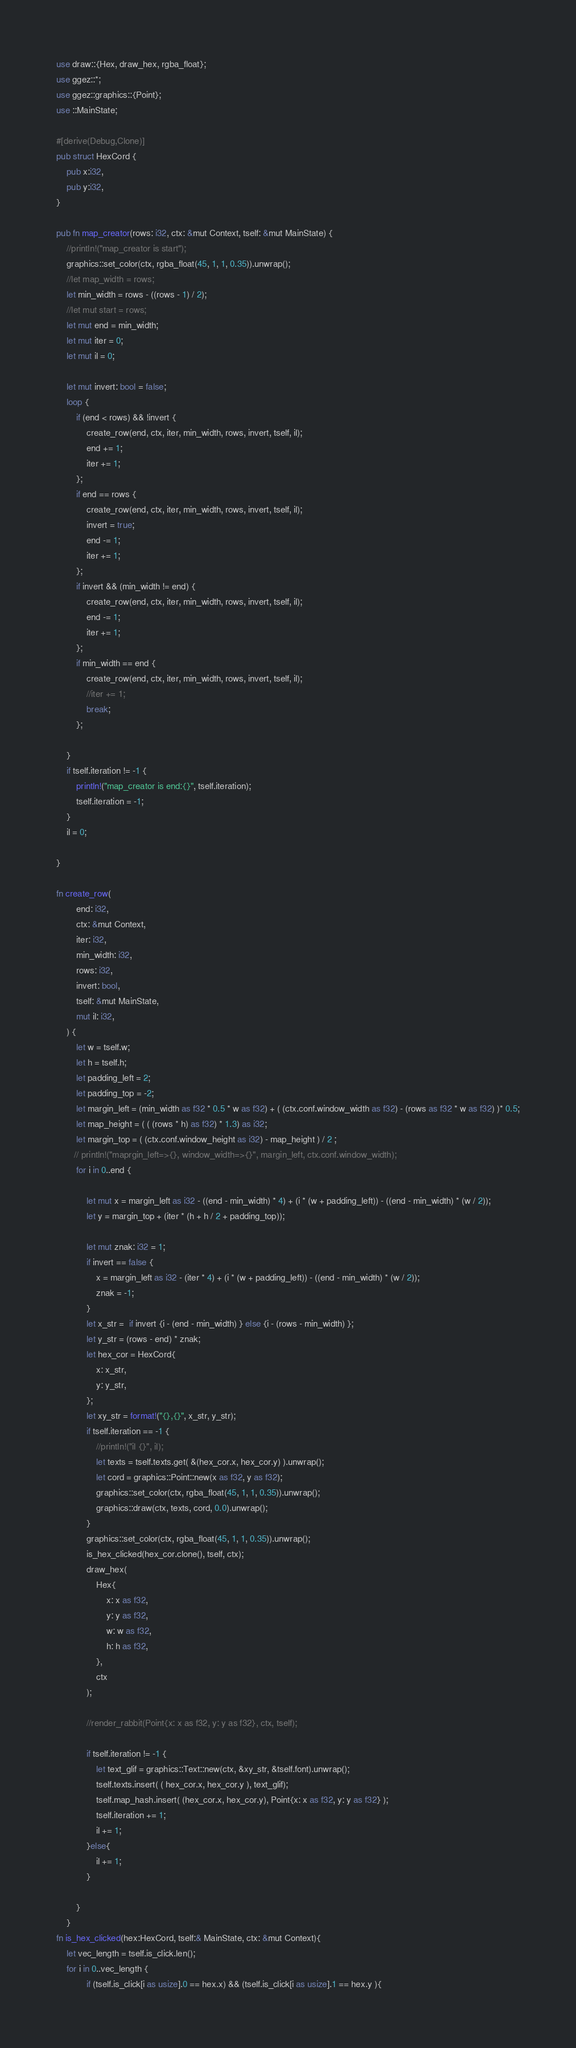Convert code to text. <code><loc_0><loc_0><loc_500><loc_500><_Rust_>use draw::{Hex, draw_hex, rgba_float};
use ggez::*;
use ggez::graphics::{Point};
use ::MainState;

#[derive(Debug,Clone)]
pub struct HexCord {
    pub x:i32,
    pub y:i32,
}

pub fn map_creator(rows: i32, ctx: &mut Context, tself: &mut MainState) {
    //println!("map_creator is start");
    graphics::set_color(ctx, rgba_float(45, 1, 1, 0.35)).unwrap();
    //let map_width = rows;
    let min_width = rows - ((rows - 1) / 2);
    //let mut start = rows;
    let mut end = min_width;
    let mut iter = 0;
    let mut il = 0;
    
    let mut invert: bool = false;
    loop {
        if (end < rows) && !invert {
            create_row(end, ctx, iter, min_width, rows, invert, tself, il);
            end += 1;
            iter += 1;
        };
        if end == rows {
            create_row(end, ctx, iter, min_width, rows, invert, tself, il);
            invert = true;
            end -= 1;
            iter += 1;
        };
        if invert && (min_width != end) {
            create_row(end, ctx, iter, min_width, rows, invert, tself, il);
            end -= 1;
            iter += 1;
        };
        if min_width == end {
            create_row(end, ctx, iter, min_width, rows, invert, tself, il);
            //iter += 1;
            break;
        };

    }
    if tself.iteration != -1 {
    	println!("map_creator is end:{}", tself.iteration);
    	tself.iteration = -1;
    }
    il = 0;
    
}

fn create_row(
        end: i32,
        ctx: &mut Context,
        iter: i32,
        min_width: i32,
        rows: i32,
        invert: bool,
        tself: &mut MainState,
        mut il: i32,
    ) {
        let w = tself.w;
        let h = tself.h;
        let padding_left = 2;
        let padding_top = -2;
        let margin_left = (min_width as f32 * 0.5 * w as f32) + ( (ctx.conf.window_width as f32) - (rows as f32 * w as f32) )* 0.5;
        let map_height = ( ( (rows * h) as f32) * 1.3) as i32;
        let margin_top = ( (ctx.conf.window_height as i32) - map_height ) / 2 ;
       // println!("maprgin_left=>{}, window_width=>{}", margin_left, ctx.conf.window_width);
        for i in 0..end {

            let mut x = margin_left as i32 - ((end - min_width) * 4) + (i * (w + padding_left)) - ((end - min_width) * (w / 2));
            let y = margin_top + (iter * (h + h / 2 + padding_top));

            let mut znak: i32 = 1;
            if invert == false {
                x = margin_left as i32 - (iter * 4) + (i * (w + padding_left)) - ((end - min_width) * (w / 2));
                znak = -1;
            }
            let x_str =  if invert {i - (end - min_width) } else {i - (rows - min_width) };
            let y_str = (rows - end) * znak;
            let hex_cor = HexCord{
            	x: x_str,
            	y: y_str,
            };
            let xy_str = format!("{},{}", x_str, y_str);
            if tself.iteration == -1 {
            	//println!("il {}", il);
            	let texts = tself.texts.get( &(hex_cor.x, hex_cor.y) ).unwrap();
            	let cord = graphics::Point::new(x as f32, y as f32);
    			graphics::set_color(ctx, rgba_float(45, 1, 1, 0.35)).unwrap();
                graphics::draw(ctx, texts, cord, 0.0).unwrap();           
            }
            graphics::set_color(ctx, rgba_float(45, 1, 1, 0.35)).unwrap();
            is_hex_clicked(hex_cor.clone(), tself, ctx);
            draw_hex(
                Hex{
                    x: x as f32,
                    y: y as f32,
                    w: w as f32,
                    h: h as f32,
                }, 
                ctx
            );
            
            //render_rabbit(Point{x: x as f32, y: y as f32}, ctx, tself);
           
            if tself.iteration != -1 {
				let text_glif = graphics::Text::new(ctx, &xy_str, &tself.font).unwrap();
            	tself.texts.insert( ( hex_cor.x, hex_cor.y ), text_glif);
                tself.map_hash.insert( (hex_cor.x, hex_cor.y), Point{x: x as f32, y: y as f32} );
            	tself.iteration += 1;
            	il += 1;            	
            }else{
            	il += 1;  
            }
            
        }
    }
fn is_hex_clicked(hex:HexCord, tself:& MainState, ctx: &mut Context){
    let vec_length = tself.is_click.len();
    for i in 0..vec_length {
            if (tself.is_click[i as usize].0 == hex.x) && (tself.is_click[i as usize].1 == hex.y ){</code> 